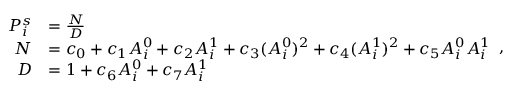<formula> <loc_0><loc_0><loc_500><loc_500>\begin{array} { r l } { P _ { i } ^ { s } } & { = \frac { N } { D } } \\ { N } & { = c _ { 0 } + c _ { 1 } A _ { i } ^ { 0 } + c _ { 2 } A _ { i } ^ { 1 } + c _ { 3 } ( A _ { i } ^ { 0 } ) ^ { 2 } + c _ { 4 } ( A _ { i } ^ { 1 } ) ^ { 2 } + c _ { 5 } A _ { i } ^ { 0 } A _ { i } ^ { 1 } } \\ { D } & { = 1 + c _ { 6 } A _ { i } ^ { 0 } + c _ { 7 } A _ { i } ^ { 1 } } \end{array} ,</formula> 